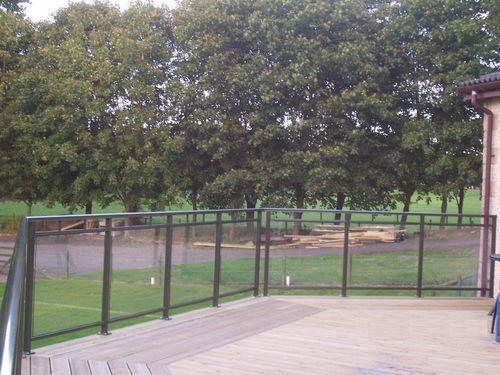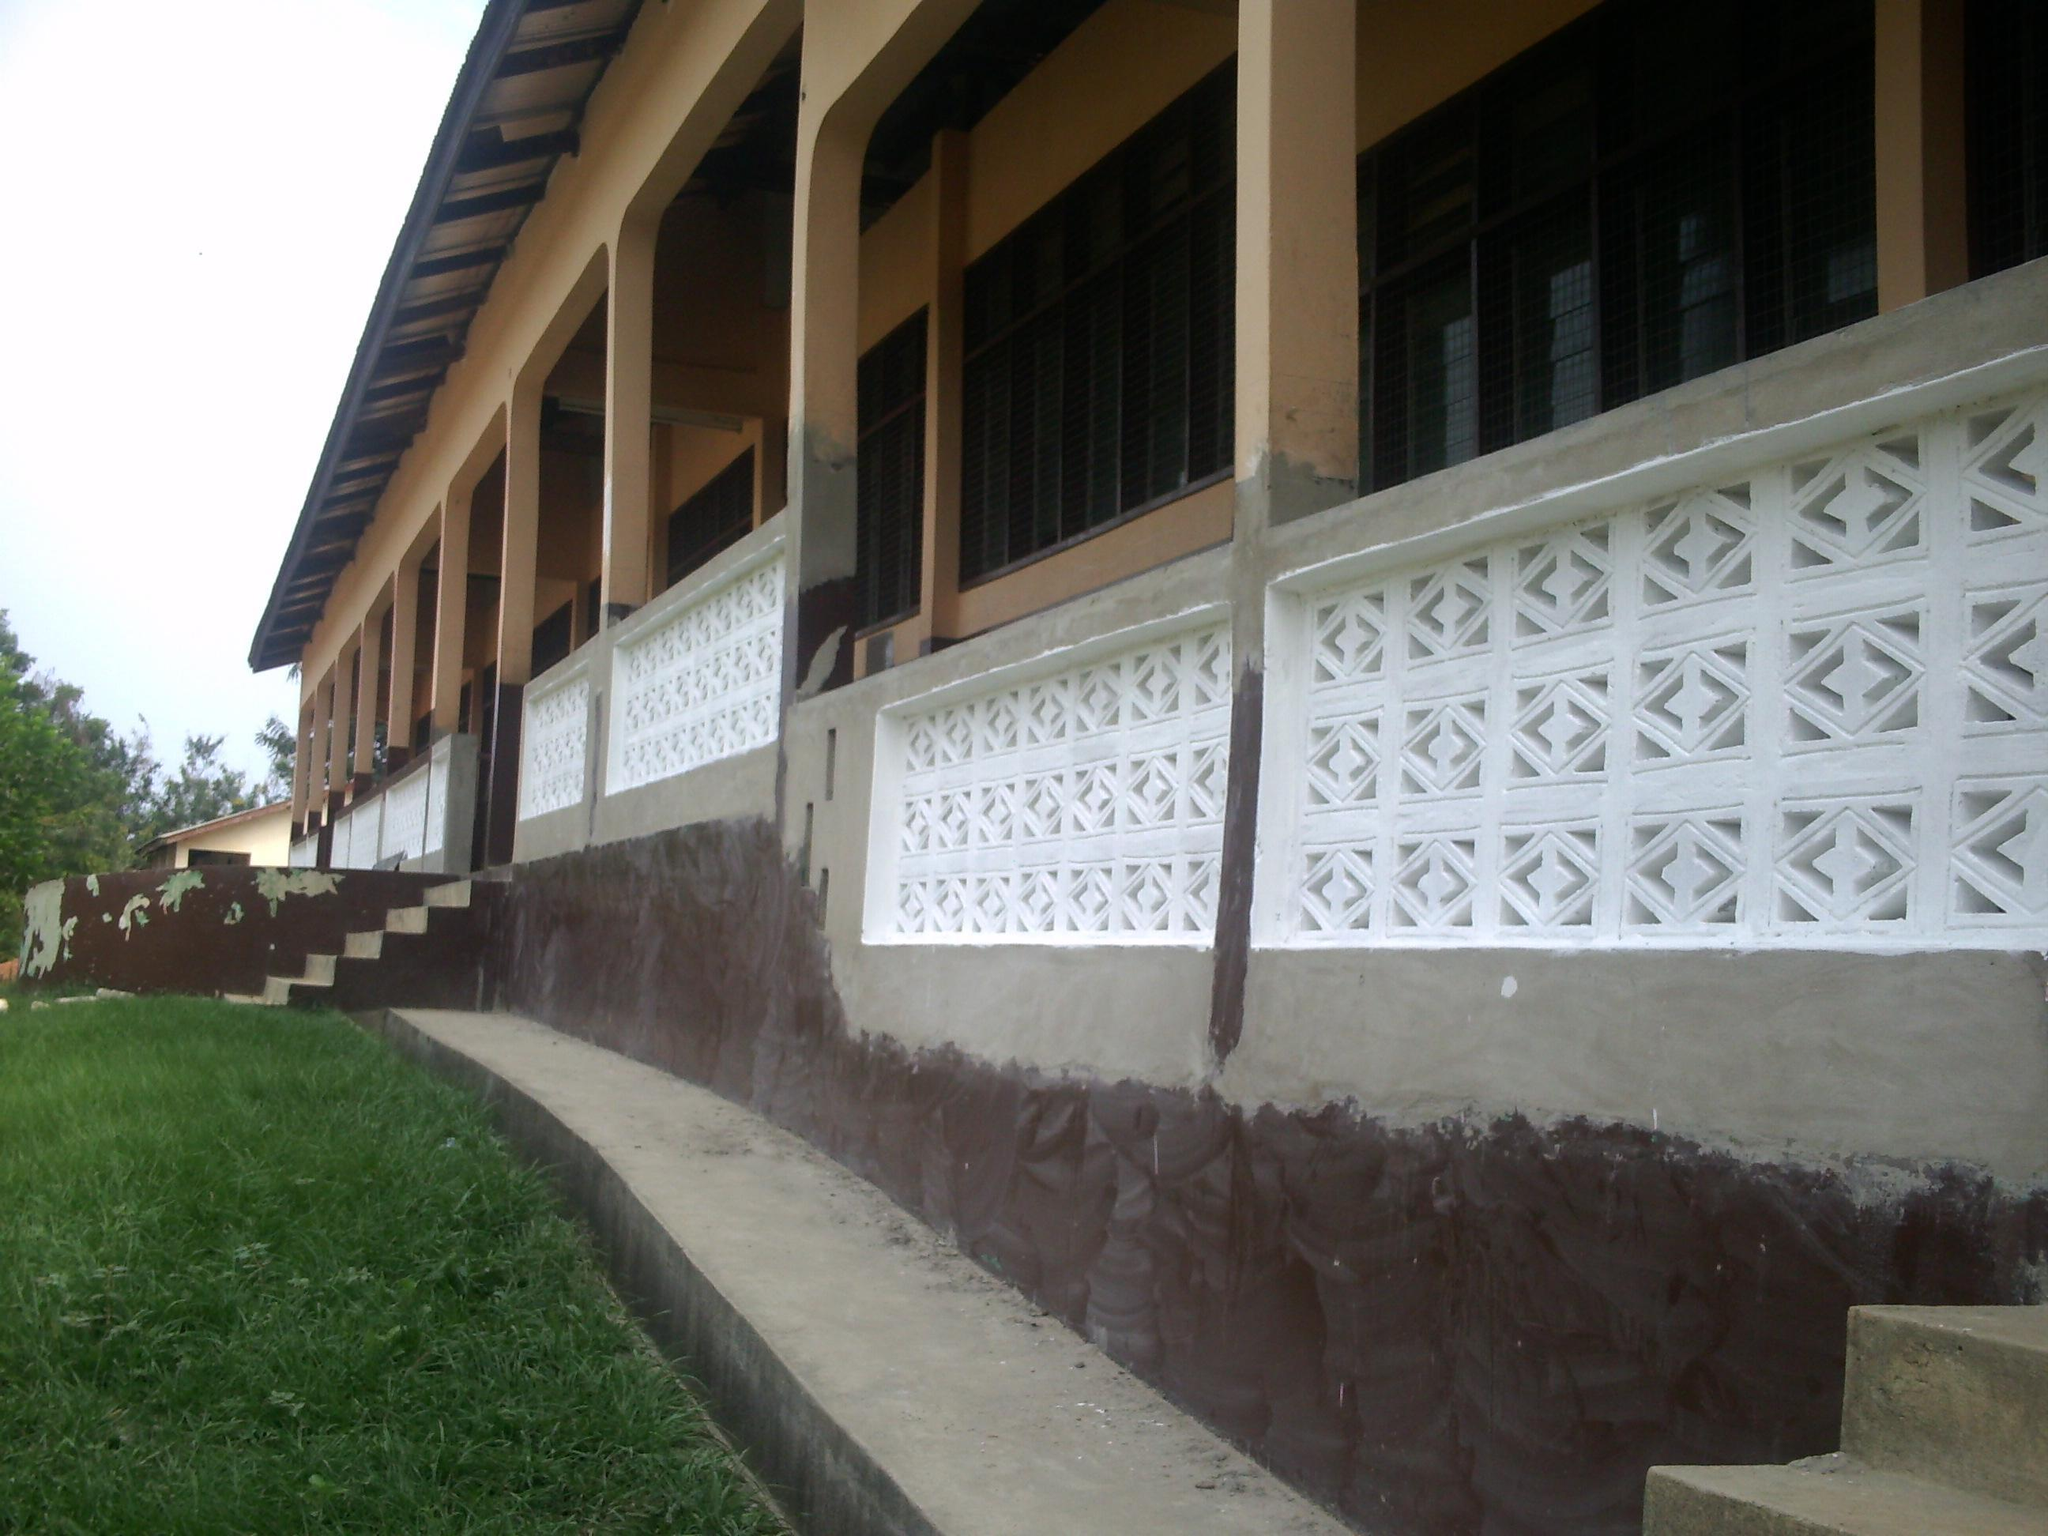The first image is the image on the left, the second image is the image on the right. Evaluate the accuracy of this statement regarding the images: "The right image shows a straight metal rail with vertical bars at the edge of a stained brown plank deck that overlooks dense foliage and trees.". Is it true? Answer yes or no. No. The first image is the image on the left, the second image is the image on the right. Considering the images on both sides, is "In at least one image there are columns attached to the building and at least a strip of cement." valid? Answer yes or no. Yes. 